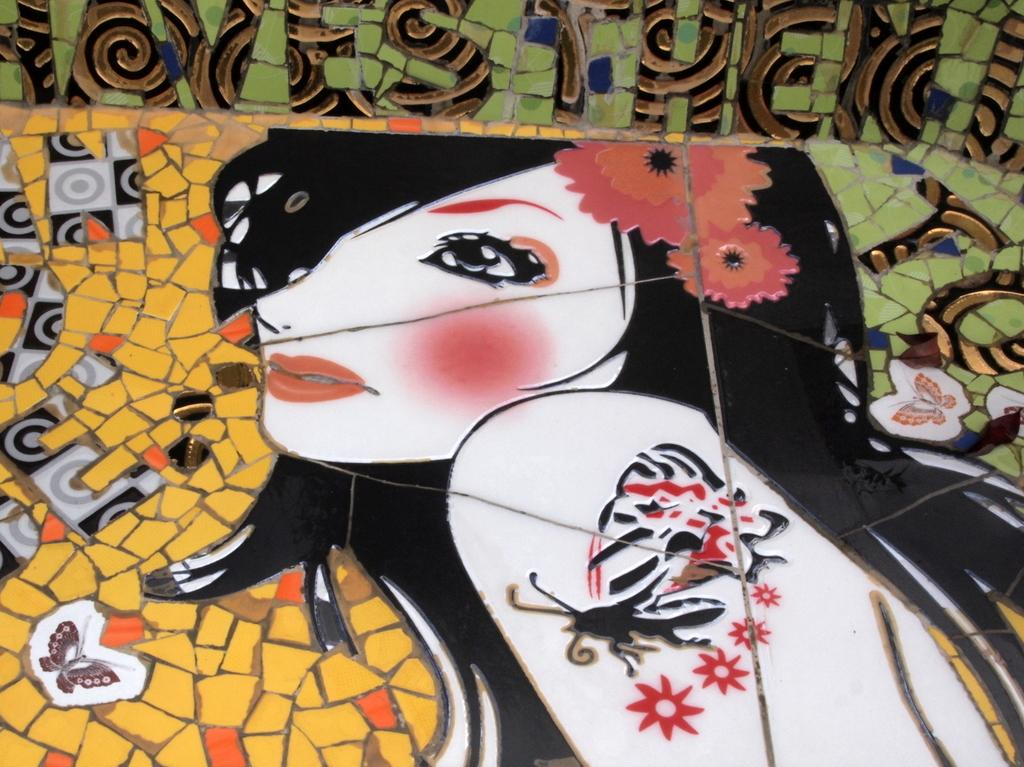What type of artwork is depicted in the image? The image is a painting. What subject is featured in the painting? There is a picture of a woman in the painting. Are there any additional elements in the painting besides the woman? Yes, there are butterflies in the painting. Where can the lunchroom be found in the painting? There is no lunchroom present in the painting; it is a painting of a woman and butterflies. What type of wind, such as a zephyr, can be seen in the painting? There is no wind or zephyr depicted in the painting; it features a woman and butterflies. 